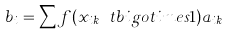Convert formula to latex. <formula><loc_0><loc_0><loc_500><loc_500>b _ { i } = \sum f ( x _ { i k } \ t b i g o t i m e s 1 ) a _ { i k }</formula> 